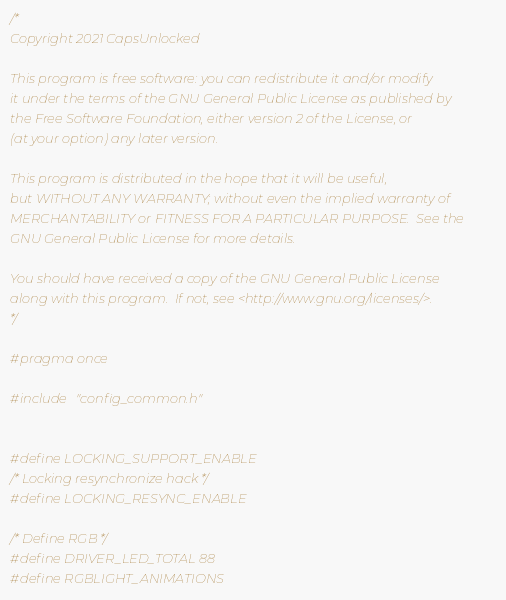Convert code to text. <code><loc_0><loc_0><loc_500><loc_500><_C_>/*
Copyright 2021 CapsUnlocked

This program is free software: you can redistribute it and/or modify
it under the terms of the GNU General Public License as published by
the Free Software Foundation, either version 2 of the License, or
(at your option) any later version.

This program is distributed in the hope that it will be useful,
but WITHOUT ANY WARRANTY; without even the implied warranty of
MERCHANTABILITY or FITNESS FOR A PARTICULAR PURPOSE.  See the
GNU General Public License for more details.

You should have received a copy of the GNU General Public License
along with this program.  If not, see <http://www.gnu.org/licenses/>.
*/

#pragma once

#include "config_common.h"


#define LOCKING_SUPPORT_ENABLE
/* Locking resynchronize hack */
#define LOCKING_RESYNC_ENABLE

/* Define RGB */
#define DRIVER_LED_TOTAL 88
#define RGBLIGHT_ANIMATIONS
</code> 